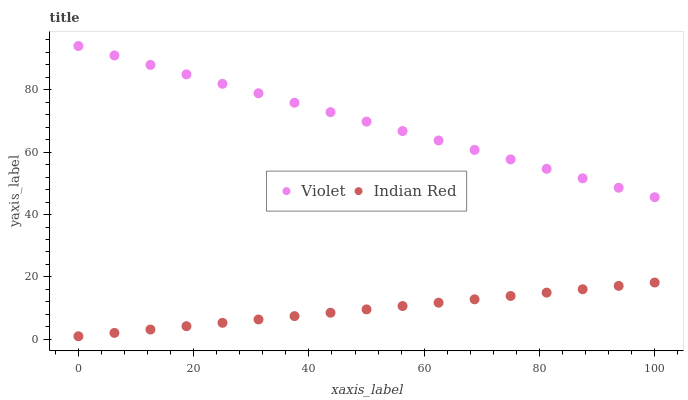Does Indian Red have the minimum area under the curve?
Answer yes or no. Yes. Does Violet have the maximum area under the curve?
Answer yes or no. Yes. Does Violet have the minimum area under the curve?
Answer yes or no. No. Is Indian Red the smoothest?
Answer yes or no. Yes. Is Violet the roughest?
Answer yes or no. Yes. Is Violet the smoothest?
Answer yes or no. No. Does Indian Red have the lowest value?
Answer yes or no. Yes. Does Violet have the lowest value?
Answer yes or no. No. Does Violet have the highest value?
Answer yes or no. Yes. Is Indian Red less than Violet?
Answer yes or no. Yes. Is Violet greater than Indian Red?
Answer yes or no. Yes. Does Indian Red intersect Violet?
Answer yes or no. No. 